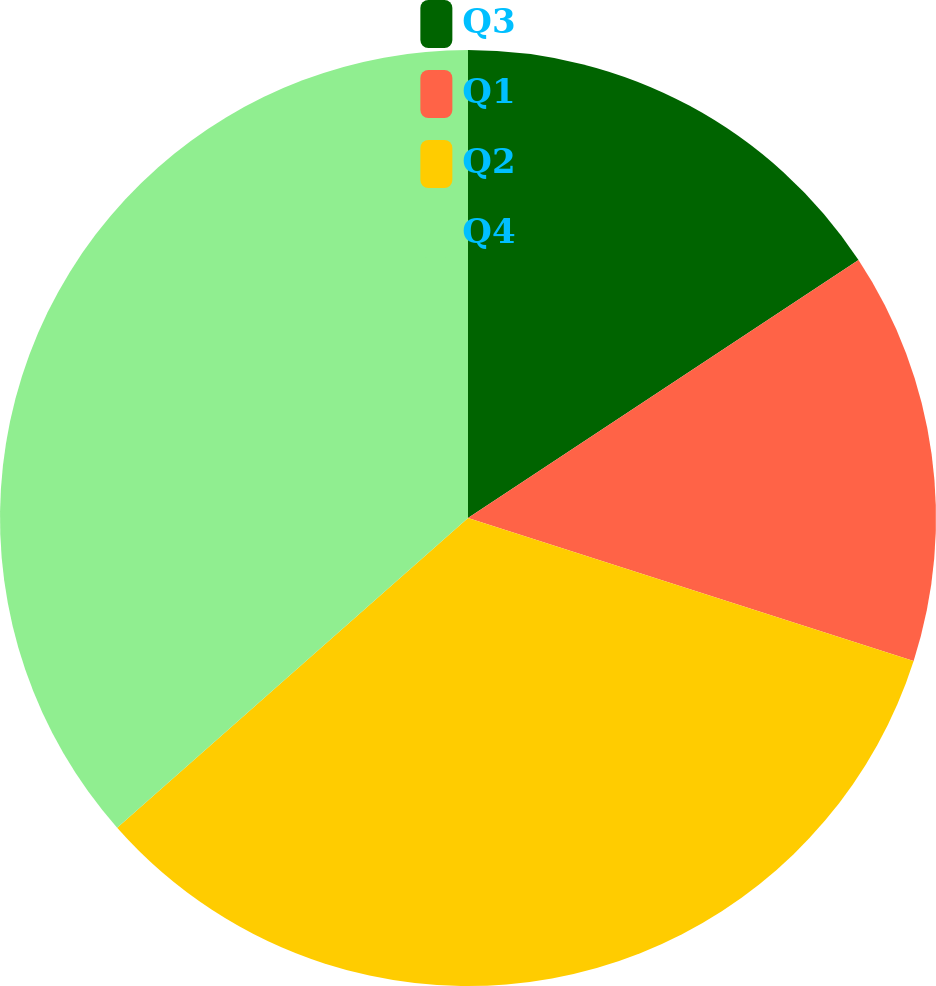<chart> <loc_0><loc_0><loc_500><loc_500><pie_chart><fcel>Q3<fcel>Q1<fcel>Q2<fcel>Q4<nl><fcel>15.71%<fcel>14.23%<fcel>33.55%<fcel>36.51%<nl></chart> 